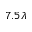Convert formula to latex. <formula><loc_0><loc_0><loc_500><loc_500>7 . 5 \lambda</formula> 